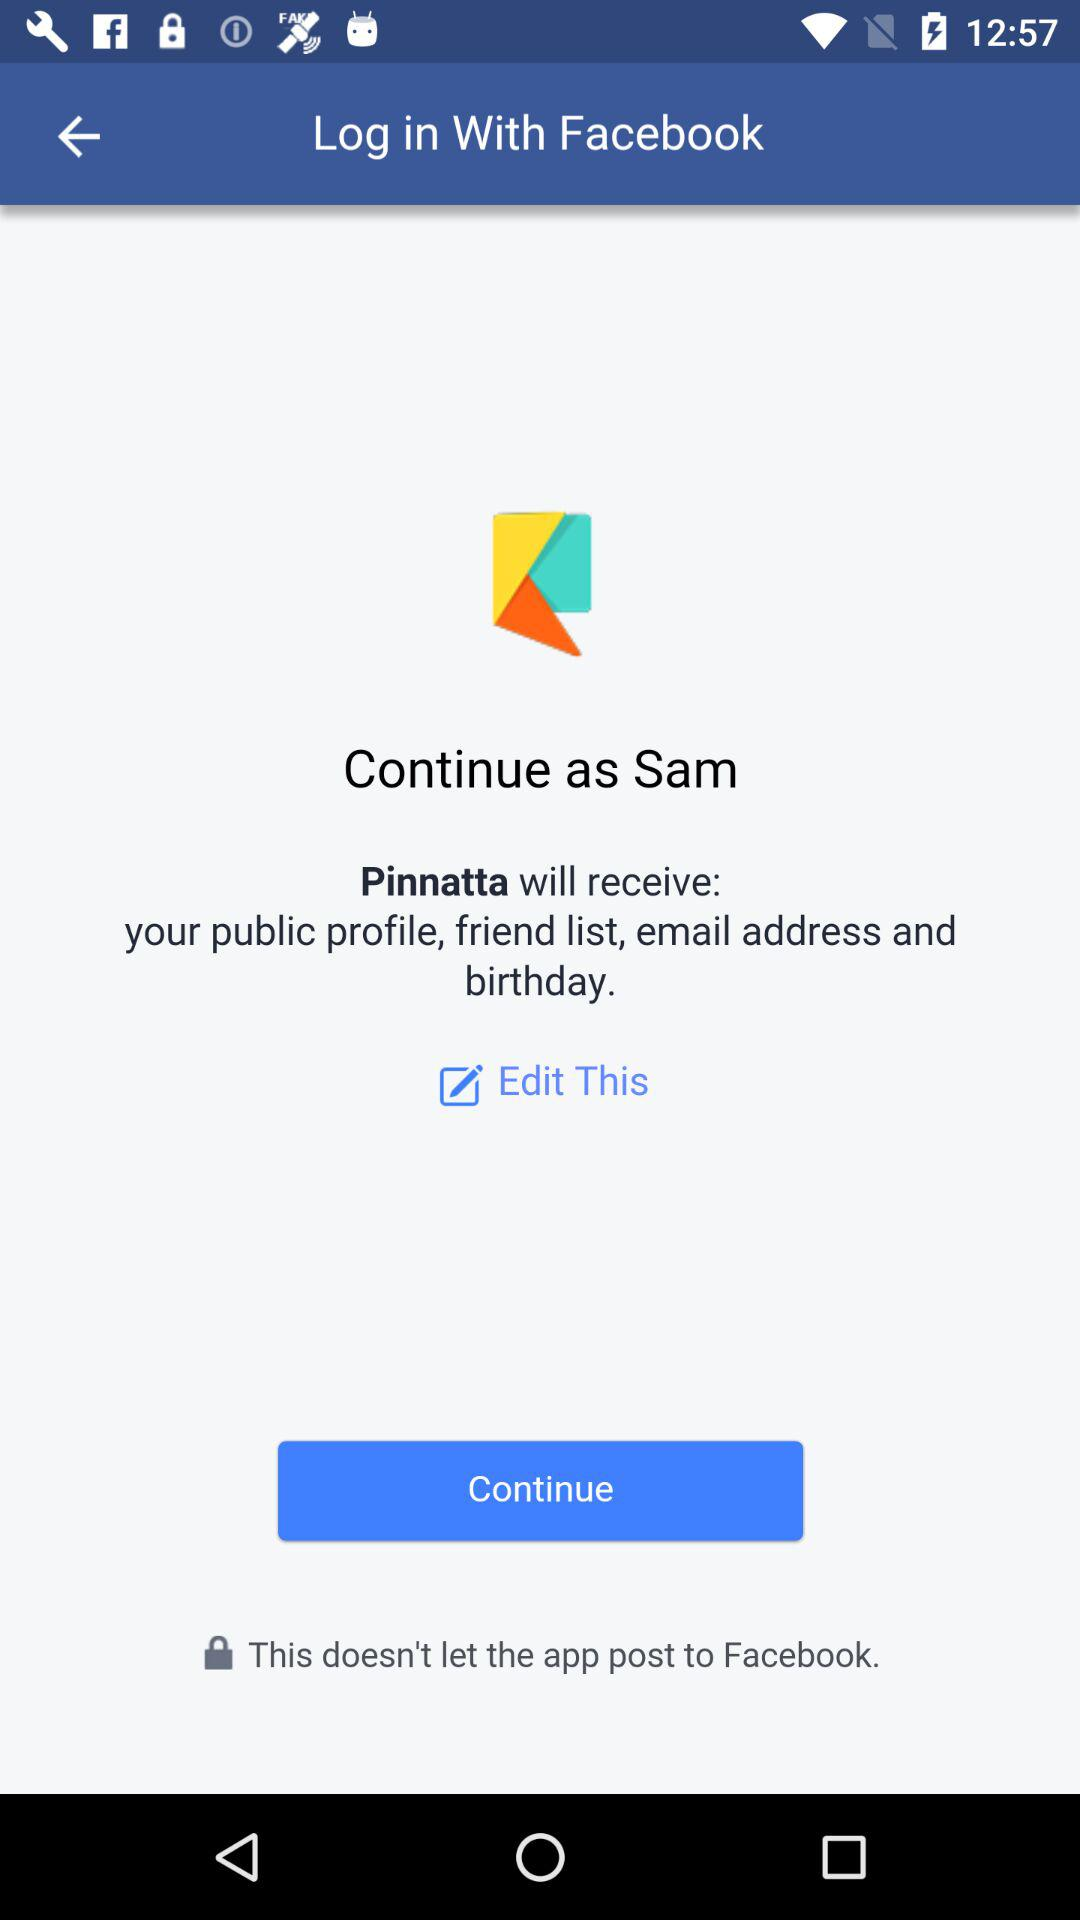What application will receive the public profile and email address? The application that will receive the public profile and email address is "Pinnatta". 